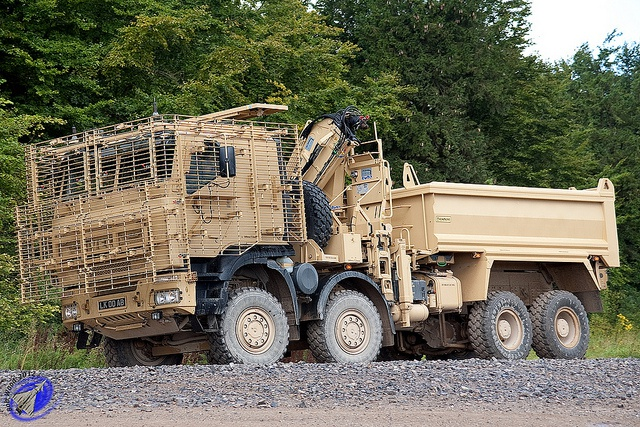Describe the objects in this image and their specific colors. I can see a truck in black, gray, and tan tones in this image. 